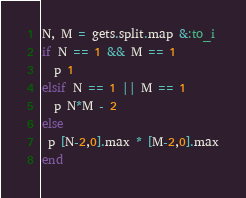Convert code to text. <code><loc_0><loc_0><loc_500><loc_500><_Ruby_>N, M = gets.split.map &:to_i
if N == 1 && M == 1
  p 1
elsif N == 1 || M == 1
  p N*M - 2
else
 p [N-2,0].max * [M-2,0].max
end
</code> 